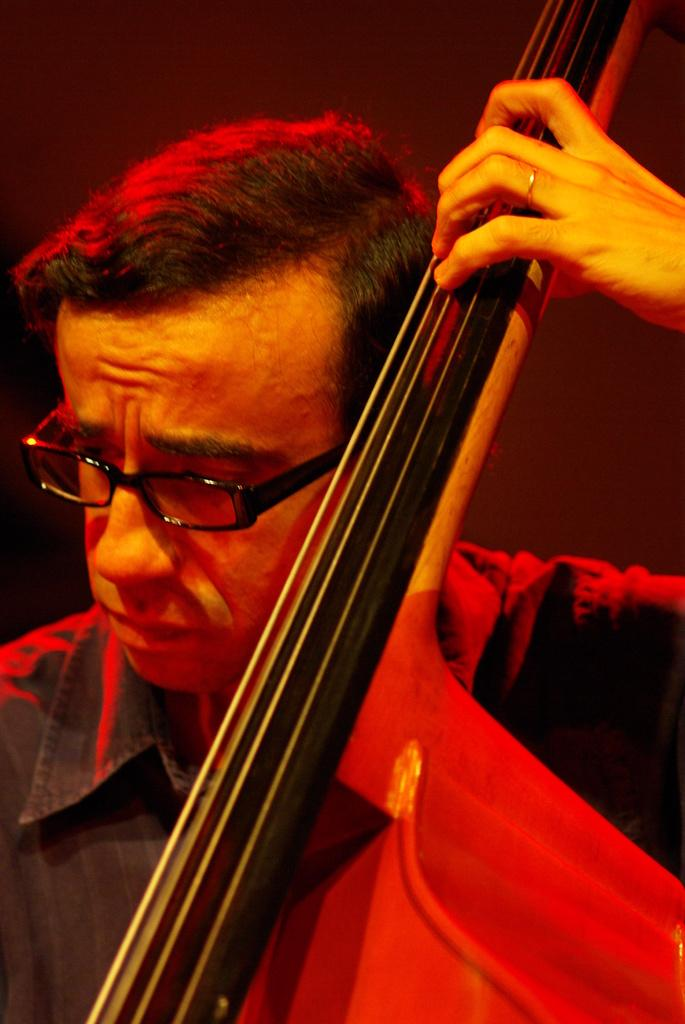What is the main subject of the image? The main subject of the image is a man. What is the man doing in the image? The man is playing a musical instrument in the image. Can you describe the man's appearance in the image? The man is wearing spectacles and a shirt in the image. What type of prison can be seen in the background of the image? There is no prison present in the image; it features a man playing a musical instrument. What kind of experience does the man have with the musical instrument he is playing? The image does not provide any information about the man's experience with the musical instrument he is playing. 